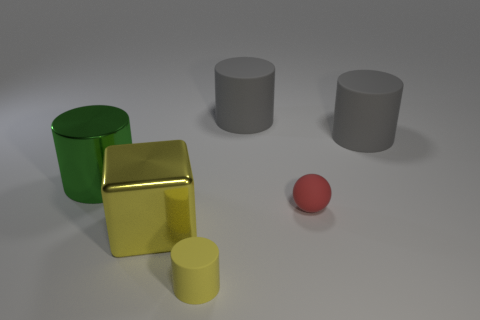How many objects are rubber cylinders that are right of the yellow rubber cylinder or tiny rubber things on the left side of the matte sphere?
Offer a terse response. 3. There is a big green thing; what shape is it?
Make the answer very short. Cylinder. What number of other things are made of the same material as the small red thing?
Offer a very short reply. 3. What size is the shiny thing that is the same shape as the small yellow matte object?
Give a very brief answer. Large. There is a yellow thing that is in front of the yellow thing that is behind the small thing that is in front of the yellow cube; what is it made of?
Provide a short and direct response. Rubber. Are there any red shiny balls?
Your response must be concise. No. There is a small rubber cylinder; does it have the same color as the metallic thing that is in front of the large green metal cylinder?
Give a very brief answer. Yes. What color is the big metal cylinder?
Your response must be concise. Green. Is there anything else that is the same shape as the red rubber thing?
Your response must be concise. No. What color is the large metallic object that is the same shape as the tiny yellow object?
Your answer should be compact. Green. 